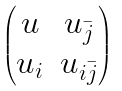<formula> <loc_0><loc_0><loc_500><loc_500>\begin{pmatrix} u & u _ { \bar { j } } \\ u _ { i } & u _ { i \bar { j } } \end{pmatrix}</formula> 